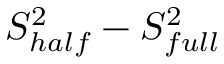Convert formula to latex. <formula><loc_0><loc_0><loc_500><loc_500>S _ { h a l f } ^ { 2 } - S _ { f u l l } ^ { 2 }</formula> 